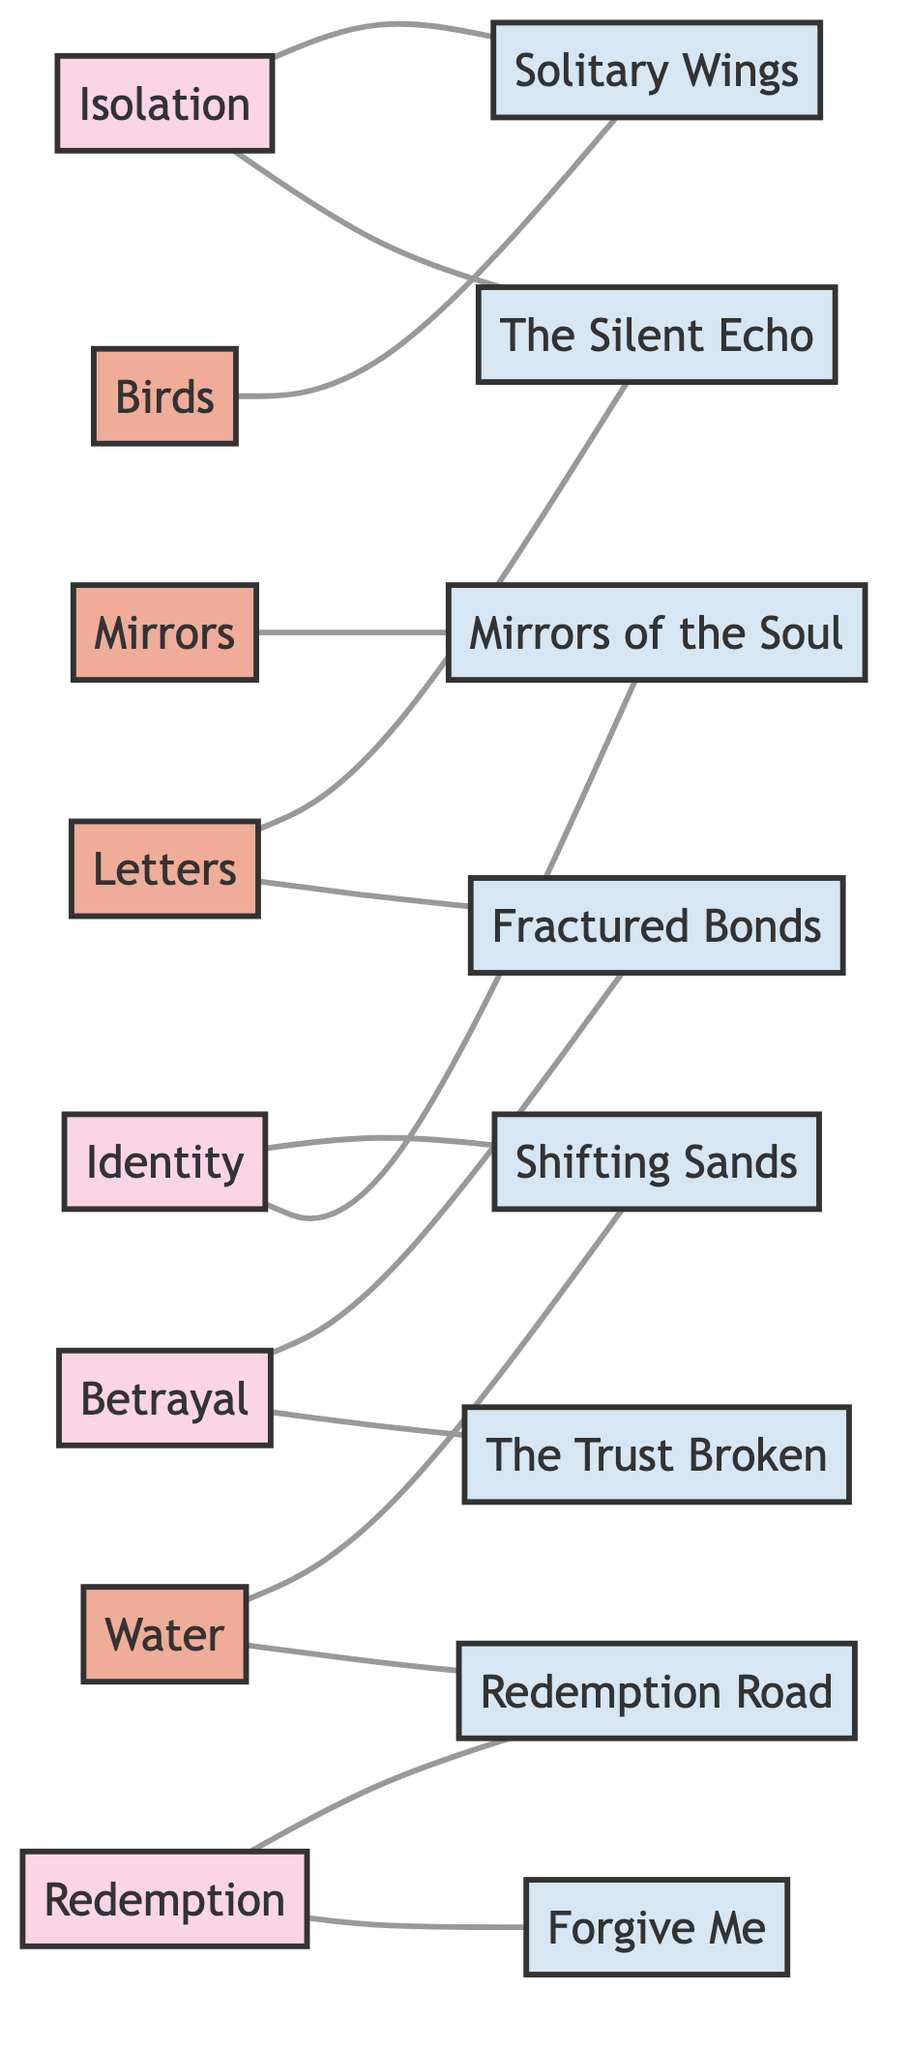What is the first theme listed in the diagram? The first theme node is "Isolation," and it is the first one mentioned in the diagram's rendering.
Answer: Isolation How many books are associated with the theme of Redemption? The theme "Redemption" is connected to two books, "Redemption Road" and "Forgive Me," evidenced by the edges leading from the theme node to the book nodes.
Answer: 2 Which motif is connected to the book "Mirrors of the Soul"? The motif "Mirrors" is associated with the book "Mirrors of the Soul," as indicated by a direct connection between the two nodes.
Answer: Mirrors What do the motifs "Birds" and "Water" symbolize in the context of the novels? "Birds" symbolize freedom and escape, while "Water" symbolizes change and cleansing, which are explicitly defined in their descriptions within the diagram.
Answer: Freedom and escape; Change and cleansing Which theme is linked to the most number of books? The theme "Isolation" is linked to two books, which is the same as "Redemption," but when considering the others, "Identity" and "Betrayal" both link to two books as well—leading to a tie among themes.
Answer: Isolation, Identity, and Betrayal How many motifs are there in total? There are four motifs listed: "Mirrors," "Birds," "Letters," and "Water." These are counted directly from the motif nodes shown in the diagram.
Answer: 4 What relationship do the motifs have with the books "The Silent Echo" and "Fractured Bonds"? Both motifs "Letters" are linked to these books, indicating that letters play a significant role in the narratives of both books.
Answer: Letters Which theme is associated with the book "The Trust Broken"? The theme "Betrayal" is associated with the book "The Trust Broken," which is indicated by the connection in the network diagram.
Answer: Betrayal How many edges are there connecting themes to books in the diagram? By counting the lines (or edges) connecting themes to their respective books, there are a total of eight edges connecting the themes and the books.
Answer: 8 